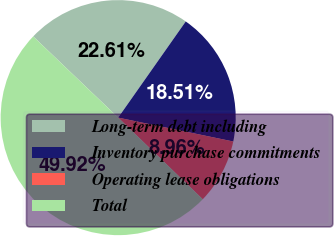<chart> <loc_0><loc_0><loc_500><loc_500><pie_chart><fcel>Long-term debt including<fcel>Inventory purchase commitments<fcel>Operating lease obligations<fcel>Total<nl><fcel>22.61%<fcel>18.51%<fcel>8.96%<fcel>49.92%<nl></chart> 